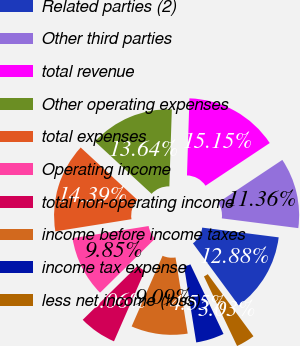Convert chart. <chart><loc_0><loc_0><loc_500><loc_500><pie_chart><fcel>Related parties (2)<fcel>Other third parties<fcel>total revenue<fcel>Other operating expenses<fcel>total expenses<fcel>Operating income<fcel>total non-operating income<fcel>income before income taxes<fcel>income tax expense<fcel>less net income (loss)<nl><fcel>12.88%<fcel>11.36%<fcel>15.15%<fcel>13.64%<fcel>14.39%<fcel>9.85%<fcel>6.06%<fcel>9.09%<fcel>4.55%<fcel>3.03%<nl></chart> 